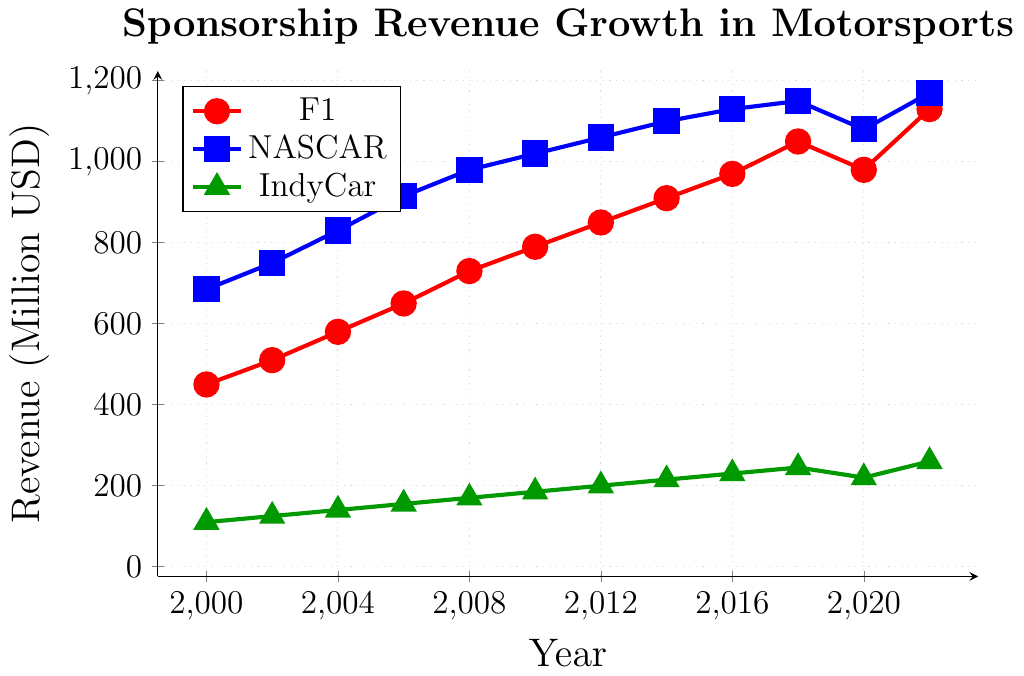What is the trend of NASCAR's sponsorship revenue from 2000 to 2022? By observing the blue line representing NASCAR in the chart, we see that the sponsorship revenue increases almost consistently from 2000 to 2018 and then experiences a slight dip in 2020 before increasing again in 2022.
Answer: Increasing with slight fluctuation Between which years did F1 see the highest increase in sponsorship revenue? The red line representing F1 shows the highest increase between 2018 and 2022, where the revenue jumps from 1050 million USD to 1130 million USD.
Answer: 2018 to 2022 How does the sponsorship revenue for IndyCar in 2022 compare to that in 2000? By comparing the points on the green line for the years 2000 and 2022, we see that sponsorship revenue for IndyCar grew from 110 million USD in 2000 to 260 million USD in 2022.
Answer: Increased significantly What happened to the sponsorship revenue for F1 between 2018 and 2020? The sponsorship revenue for F1 can be observed by the red line to have decreased from 1050 million USD in 2018 to 980 million USD in 2020.
Answer: Decreased Which motorsport had the highest sponsorship revenue in 2022? By examining the endpoints of the lines for 2022, the blue line (NASCAR) at 1170 million USD is the highest among all.
Answer: NASCAR By how much did the sponsorship revenue for NASCAR increase from 2000 to 2018? The blue line shows NASCAR's revenue increasing from 685 million USD in 2000 to 1150 million USD in 2018. The increase is 1150 - 685 = 465 million USD.
Answer: 465 million USD Which motorsport experienced the smallest change in sponsorship revenue from 2018 to 2020? Observing the changes in the lines between 2018 and 2020, IndyCar's green line shows the smallest decrease from 245 million USD to 220 million USD, a difference of 25 million USD, compared to F1's 70 million USD and NASCAR's 70 million USD decrease.
Answer: IndyCar What was the average sponsorship revenue for F1 between 2010 and 2020? The sponsorship revenues for F1 from 2010, 2012, 2014, 2016, 2018, and 2020 are 790, 850, 910, 970, 1050, and 980 million USD respectively. Summing these values results in 5550 million USD. Dividing by 6, the average is 5550 / 6 = 925 million USD.
Answer: 925 million USD Which motorsport had the most consistent revenue growth from 2000 to 2022? By visually comparing the lines, NASCAR's blue line shows a more consistent and steady upward trend with minor fluctuations compared to F1 and IndyCar.
Answer: NASCAR What is the difference in sponsorship revenue between IndyCar and F1 in 2022? The sponsorship revenue for IndyCar in 2022 is 260 million USD and for F1 is 1130 million USD. The difference is 1130 - 260 = 870 million USD.
Answer: 870 million USD 